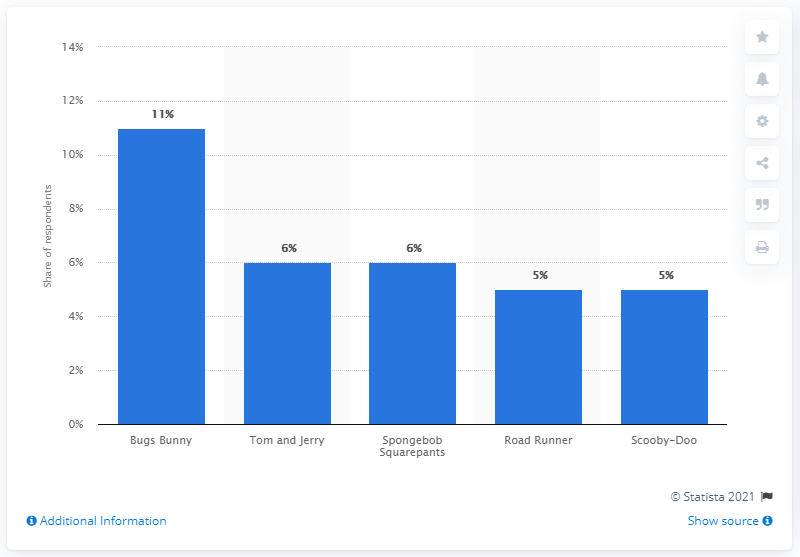List a handful of essential elements in this visual. The most popular cartoon among adults in the United States as of June 2018 was Bugs Bunny. According to data collected in June 2018, Scooby-Doo was the most popular cartoon among adults in the United States. 